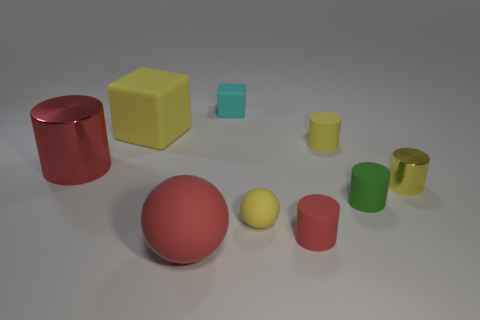What color is the big metallic thing left of the red rubber thing that is right of the tiny rubber cube?
Your answer should be very brief. Red. What number of tiny objects are either red things or yellow matte cubes?
Your answer should be very brief. 1. What is the color of the big thing that is both behind the yellow rubber ball and on the right side of the red shiny cylinder?
Keep it short and to the point. Yellow. Is the red ball made of the same material as the cyan block?
Your answer should be compact. Yes. The big red shiny object is what shape?
Your answer should be compact. Cylinder. How many yellow matte cylinders are to the right of the small matte cylinder behind the metallic thing on the left side of the yellow shiny cylinder?
Give a very brief answer. 0. What color is the small metal object that is the same shape as the big red metallic object?
Your response must be concise. Yellow. There is a red matte object behind the big object that is in front of the small red cylinder left of the tiny green rubber object; what is its shape?
Your answer should be very brief. Cylinder. There is a object that is both in front of the tiny green thing and left of the cyan matte cube; what size is it?
Make the answer very short. Large. Are there fewer small things than objects?
Keep it short and to the point. Yes. 